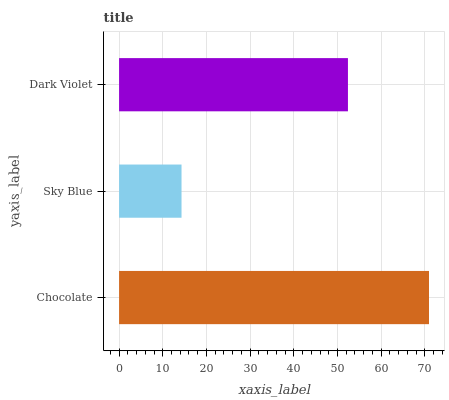Is Sky Blue the minimum?
Answer yes or no. Yes. Is Chocolate the maximum?
Answer yes or no. Yes. Is Dark Violet the minimum?
Answer yes or no. No. Is Dark Violet the maximum?
Answer yes or no. No. Is Dark Violet greater than Sky Blue?
Answer yes or no. Yes. Is Sky Blue less than Dark Violet?
Answer yes or no. Yes. Is Sky Blue greater than Dark Violet?
Answer yes or no. No. Is Dark Violet less than Sky Blue?
Answer yes or no. No. Is Dark Violet the high median?
Answer yes or no. Yes. Is Dark Violet the low median?
Answer yes or no. Yes. Is Chocolate the high median?
Answer yes or no. No. Is Sky Blue the low median?
Answer yes or no. No. 